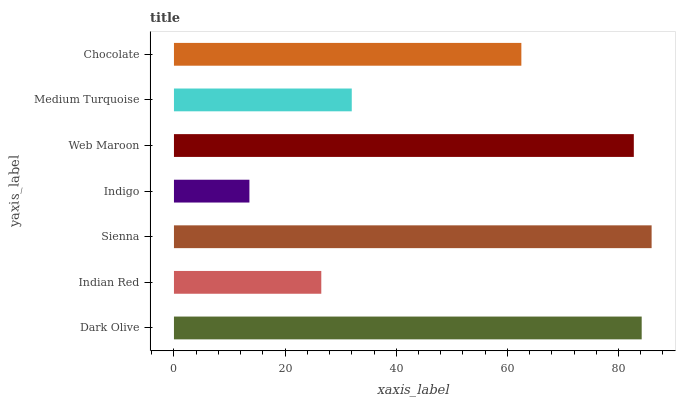Is Indigo the minimum?
Answer yes or no. Yes. Is Sienna the maximum?
Answer yes or no. Yes. Is Indian Red the minimum?
Answer yes or no. No. Is Indian Red the maximum?
Answer yes or no. No. Is Dark Olive greater than Indian Red?
Answer yes or no. Yes. Is Indian Red less than Dark Olive?
Answer yes or no. Yes. Is Indian Red greater than Dark Olive?
Answer yes or no. No. Is Dark Olive less than Indian Red?
Answer yes or no. No. Is Chocolate the high median?
Answer yes or no. Yes. Is Chocolate the low median?
Answer yes or no. Yes. Is Sienna the high median?
Answer yes or no. No. Is Medium Turquoise the low median?
Answer yes or no. No. 